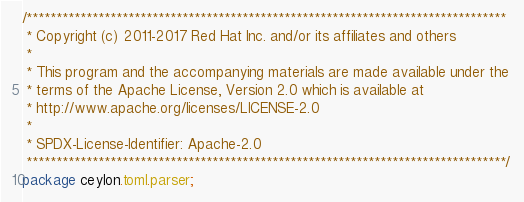<code> <loc_0><loc_0><loc_500><loc_500><_Ceylon_>/********************************************************************************
 * Copyright (c) 2011-2017 Red Hat Inc. and/or its affiliates and others
 *
 * This program and the accompanying materials are made available under the 
 * terms of the Apache License, Version 2.0 which is available at
 * http://www.apache.org/licenses/LICENSE-2.0
 *
 * SPDX-License-Identifier: Apache-2.0 
 ********************************************************************************/
package ceylon.toml.parser;
</code> 